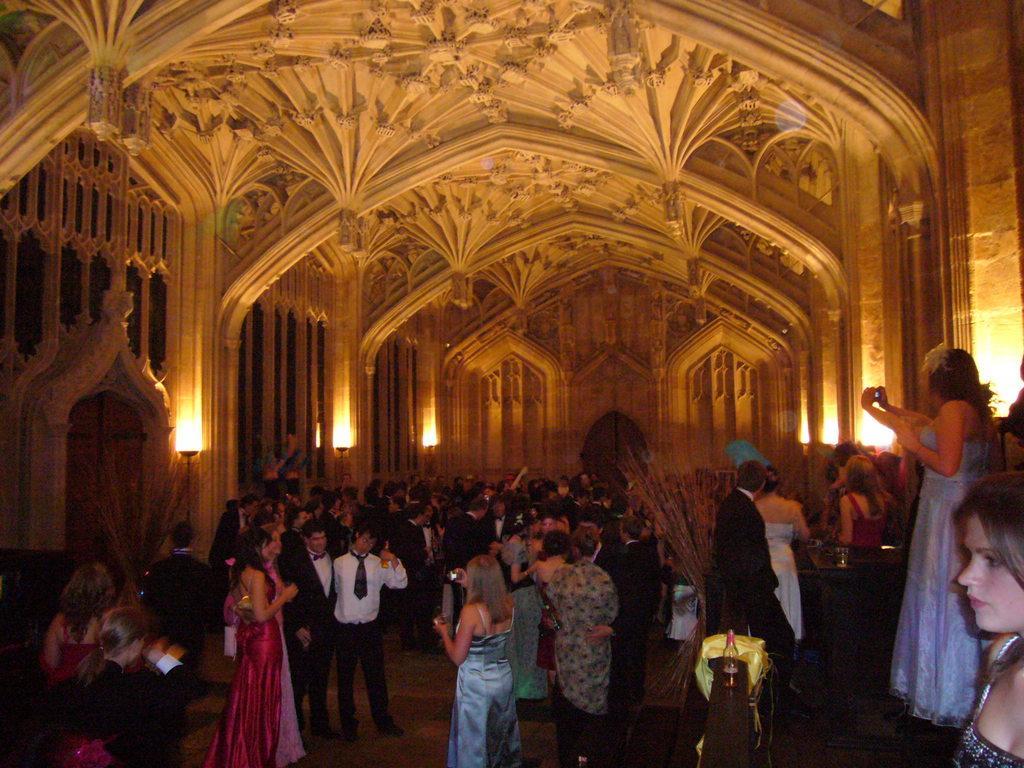Could you give a brief overview of what you see in this image? This image is taken from inside, in this image there are so many people standing and holding some objects in their hands, there are a few lamps hanging on the wall. At the top of the image there is a ceiling. 